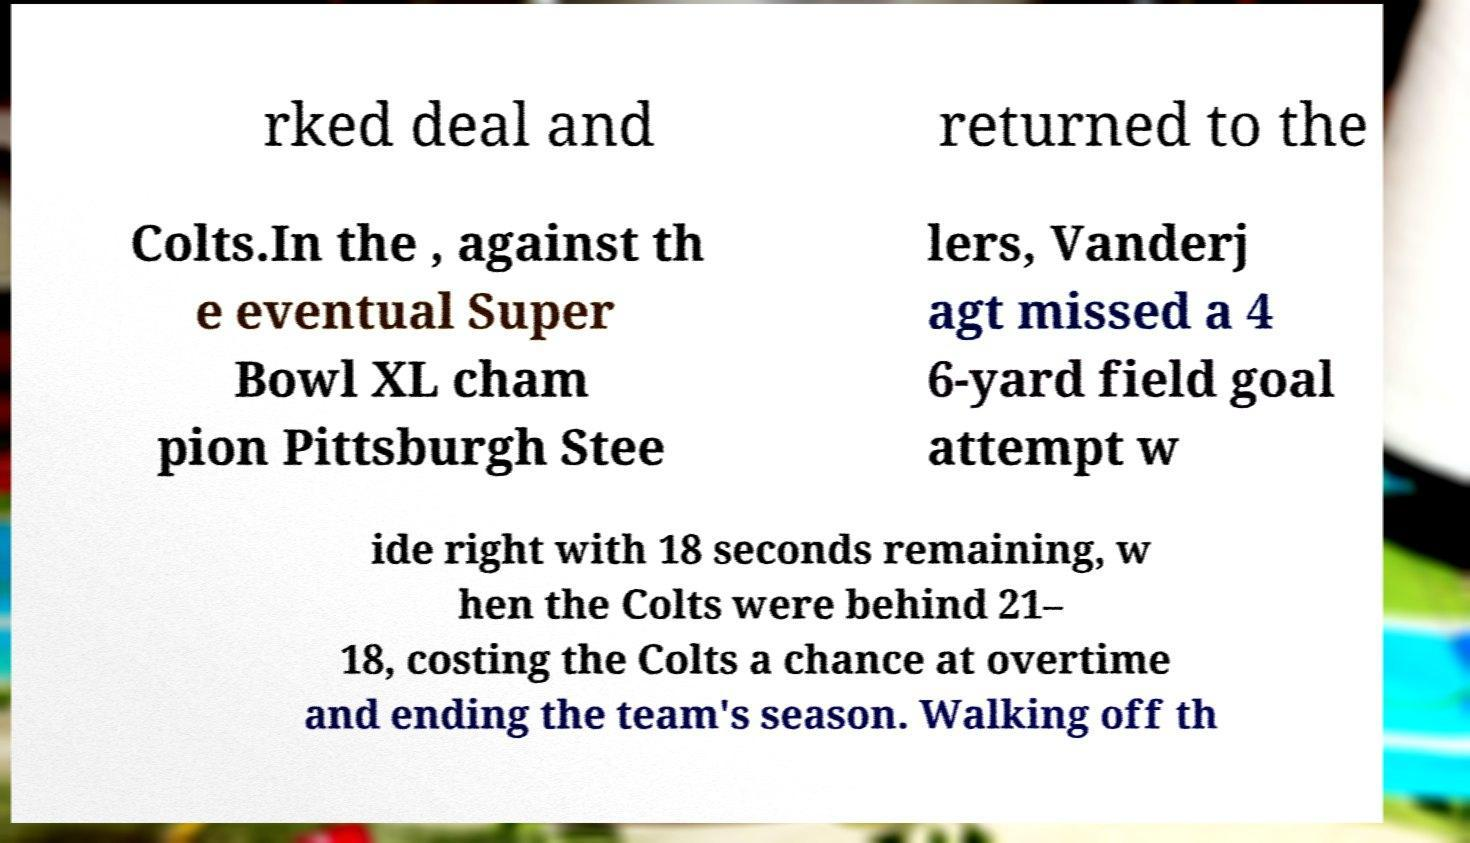Could you assist in decoding the text presented in this image and type it out clearly? rked deal and returned to the Colts.In the , against th e eventual Super Bowl XL cham pion Pittsburgh Stee lers, Vanderj agt missed a 4 6-yard field goal attempt w ide right with 18 seconds remaining, w hen the Colts were behind 21– 18, costing the Colts a chance at overtime and ending the team's season. Walking off th 